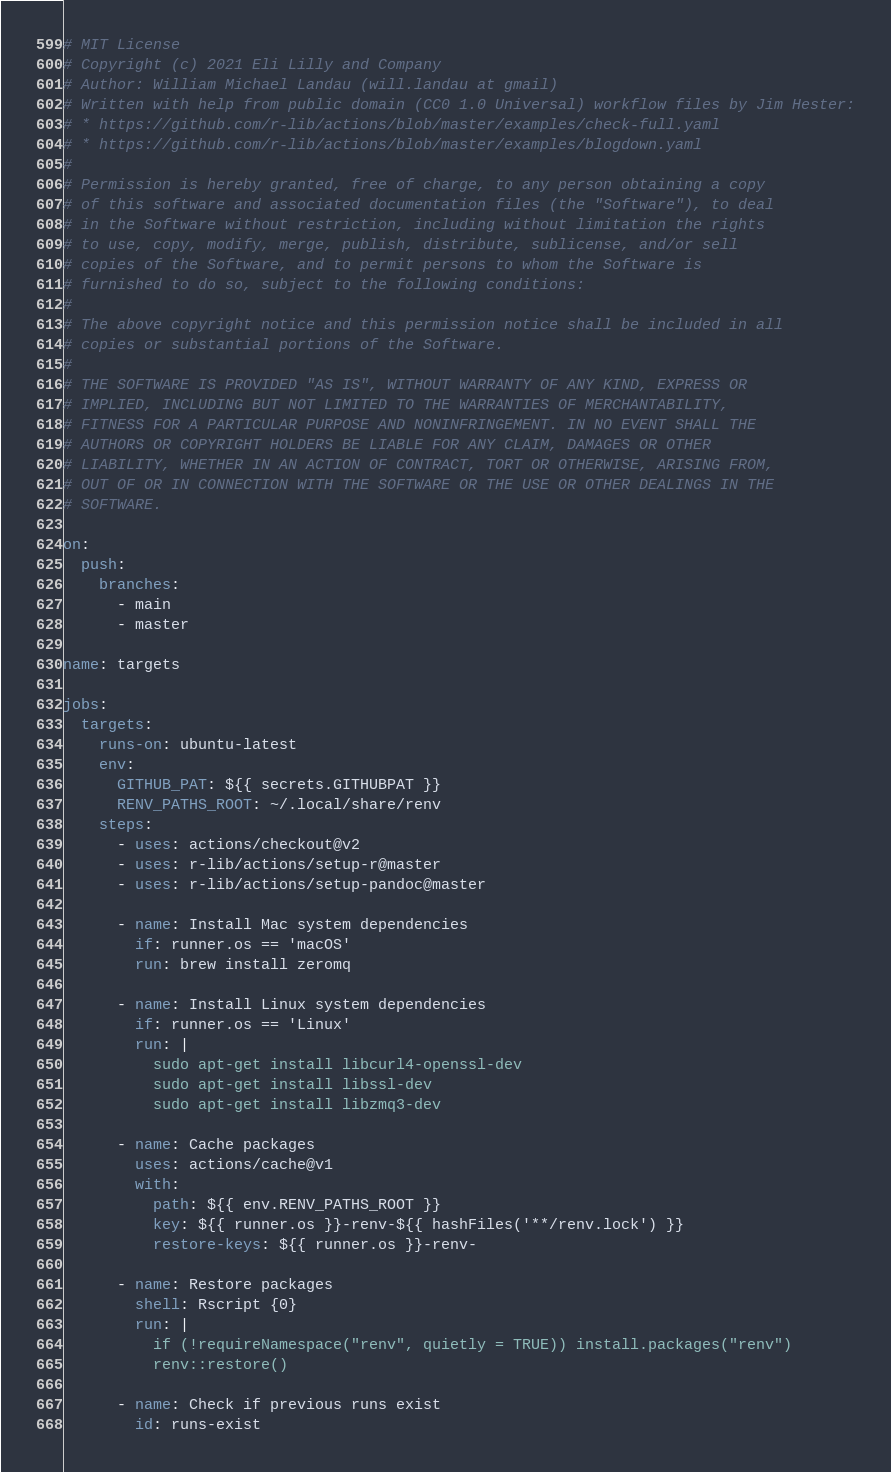<code> <loc_0><loc_0><loc_500><loc_500><_YAML_># MIT License
# Copyright (c) 2021 Eli Lilly and Company
# Author: William Michael Landau (will.landau at gmail)
# Written with help from public domain (CC0 1.0 Universal) workflow files by Jim Hester:
# * https://github.com/r-lib/actions/blob/master/examples/check-full.yaml
# * https://github.com/r-lib/actions/blob/master/examples/blogdown.yaml
#
# Permission is hereby granted, free of charge, to any person obtaining a copy
# of this software and associated documentation files (the "Software"), to deal
# in the Software without restriction, including without limitation the rights
# to use, copy, modify, merge, publish, distribute, sublicense, and/or sell
# copies of the Software, and to permit persons to whom the Software is
# furnished to do so, subject to the following conditions:
#
# The above copyright notice and this permission notice shall be included in all
# copies or substantial portions of the Software.
#
# THE SOFTWARE IS PROVIDED "AS IS", WITHOUT WARRANTY OF ANY KIND, EXPRESS OR
# IMPLIED, INCLUDING BUT NOT LIMITED TO THE WARRANTIES OF MERCHANTABILITY,
# FITNESS FOR A PARTICULAR PURPOSE AND NONINFRINGEMENT. IN NO EVENT SHALL THE
# AUTHORS OR COPYRIGHT HOLDERS BE LIABLE FOR ANY CLAIM, DAMAGES OR OTHER
# LIABILITY, WHETHER IN AN ACTION OF CONTRACT, TORT OR OTHERWISE, ARISING FROM,
# OUT OF OR IN CONNECTION WITH THE SOFTWARE OR THE USE OR OTHER DEALINGS IN THE
# SOFTWARE.

on:
  push:
    branches:
      - main
      - master

name: targets

jobs:
  targets:
    runs-on: ubuntu-latest
    env:
      GITHUB_PAT: ${{ secrets.GITHUBPAT }}
      RENV_PATHS_ROOT: ~/.local/share/renv
    steps:
      - uses: actions/checkout@v2
      - uses: r-lib/actions/setup-r@master
      - uses: r-lib/actions/setup-pandoc@master

      - name: Install Mac system dependencies
        if: runner.os == 'macOS'
        run: brew install zeromq

      - name: Install Linux system dependencies
        if: runner.os == 'Linux'
        run: |
          sudo apt-get install libcurl4-openssl-dev
          sudo apt-get install libssl-dev
          sudo apt-get install libzmq3-dev

      - name: Cache packages
        uses: actions/cache@v1
        with:
          path: ${{ env.RENV_PATHS_ROOT }}
          key: ${{ runner.os }}-renv-${{ hashFiles('**/renv.lock') }}
          restore-keys: ${{ runner.os }}-renv-

      - name: Restore packages
        shell: Rscript {0}
        run: |
          if (!requireNamespace("renv", quietly = TRUE)) install.packages("renv")
          renv::restore()

      - name: Check if previous runs exist
        id: runs-exist</code> 